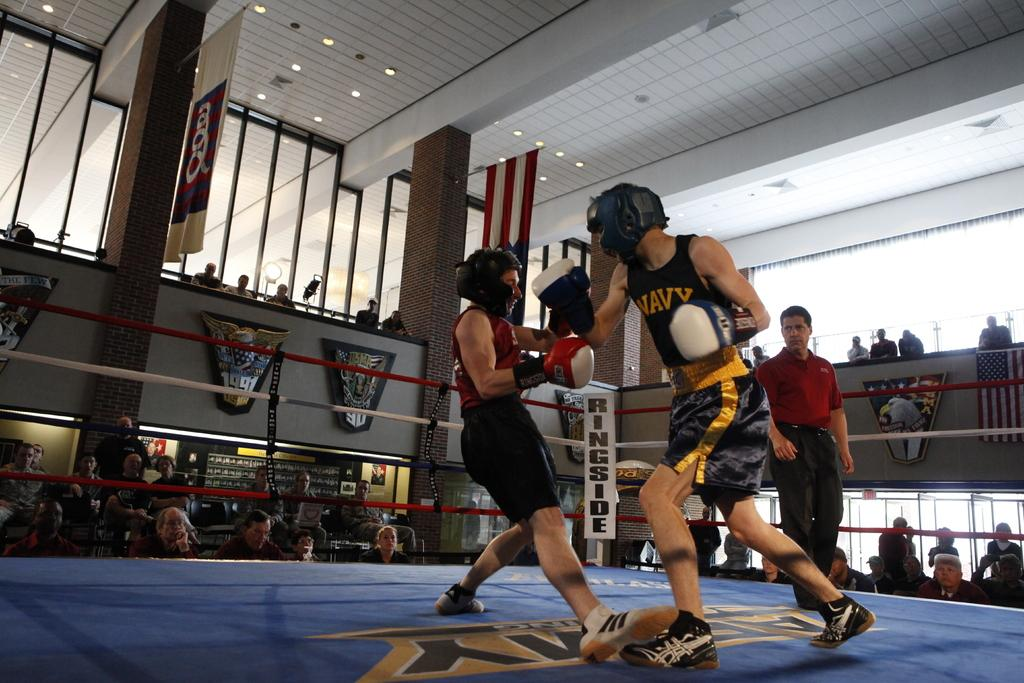<image>
Create a compact narrative representing the image presented. A couple of guys are boxing with each other as one guy is wearing a Navy shirt 